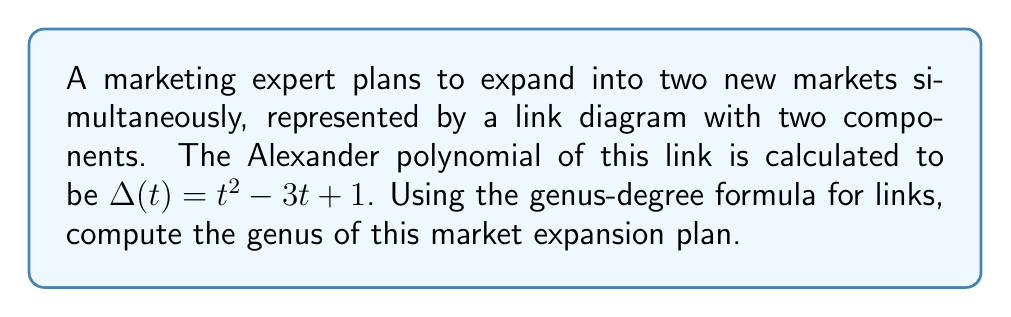Could you help me with this problem? To solve this problem, we'll use the genus-degree formula for links and the given Alexander polynomial. Let's proceed step-by-step:

1) The genus-degree formula for links states:

   $$2g(L) = \deg(\Delta(t)) + 1 - \mu(L)$$

   Where:
   - $g(L)$ is the genus of the link
   - $\deg(\Delta(t))$ is the degree of the Alexander polynomial
   - $\mu(L)$ is the number of components in the link

2) We're given that the Alexander polynomial is $\Delta(t) = t^2 - 3t + 1$

3) The degree of this polynomial is 2, so $\deg(\Delta(t)) = 2$

4) We're told that the link has two components, so $\mu(L) = 2$

5) Substituting these values into the formula:

   $$2g(L) = 2 + 1 - 2$$
   $$2g(L) = 1$$

6) Solving for $g(L)$:

   $$g(L) = \frac{1}{2}$$

Thus, the genus of the market expansion plan, represented as a link, is 1/2.
Answer: $\frac{1}{2}$ 